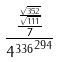Convert formula to latex. <formula><loc_0><loc_0><loc_500><loc_500>\frac { \frac { \frac { \sqrt { 3 5 2 } } { \sqrt { 1 1 1 } } } { 7 } } { { 4 ^ { 3 3 6 } } ^ { 2 9 4 } }</formula> 